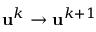Convert formula to latex. <formula><loc_0><loc_0><loc_500><loc_500>u ^ { k } \rightarrow u ^ { k + 1 }</formula> 